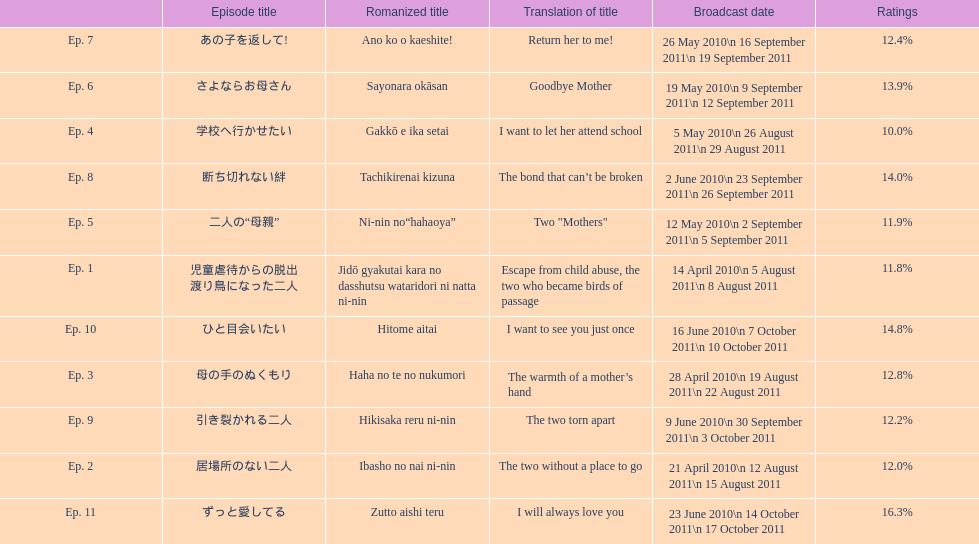What was the name of the first episode of this show? 児童虐待からの脱出 渡り鳥になった二人. 